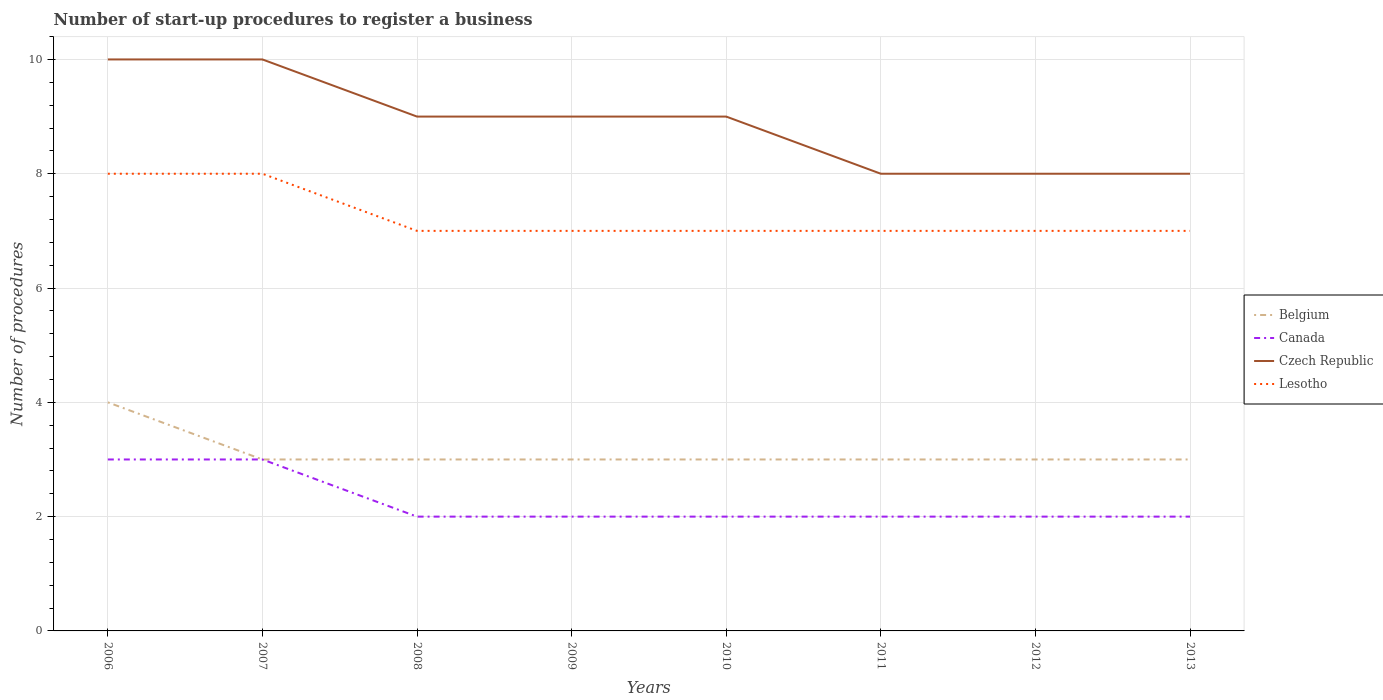How many different coloured lines are there?
Keep it short and to the point. 4. Does the line corresponding to Czech Republic intersect with the line corresponding to Canada?
Provide a succinct answer. No. Is the number of lines equal to the number of legend labels?
Provide a succinct answer. Yes. Across all years, what is the maximum number of procedures required to register a business in Lesotho?
Make the answer very short. 7. In which year was the number of procedures required to register a business in Belgium maximum?
Your answer should be compact. 2007. What is the difference between the highest and the second highest number of procedures required to register a business in Czech Republic?
Your answer should be compact. 2. What is the difference between the highest and the lowest number of procedures required to register a business in Canada?
Make the answer very short. 2. How many lines are there?
Offer a terse response. 4. How many years are there in the graph?
Keep it short and to the point. 8. What is the difference between two consecutive major ticks on the Y-axis?
Your answer should be very brief. 2. Does the graph contain any zero values?
Ensure brevity in your answer.  No. Where does the legend appear in the graph?
Offer a very short reply. Center right. How are the legend labels stacked?
Offer a very short reply. Vertical. What is the title of the graph?
Ensure brevity in your answer.  Number of start-up procedures to register a business. What is the label or title of the Y-axis?
Your answer should be very brief. Number of procedures. What is the Number of procedures in Belgium in 2007?
Your response must be concise. 3. What is the Number of procedures in Lesotho in 2007?
Provide a short and direct response. 8. What is the Number of procedures of Czech Republic in 2008?
Keep it short and to the point. 9. What is the Number of procedures of Lesotho in 2008?
Your answer should be compact. 7. What is the Number of procedures of Belgium in 2009?
Ensure brevity in your answer.  3. What is the Number of procedures in Canada in 2009?
Your response must be concise. 2. What is the Number of procedures in Lesotho in 2009?
Your answer should be very brief. 7. What is the Number of procedures in Belgium in 2010?
Give a very brief answer. 3. What is the Number of procedures in Canada in 2010?
Ensure brevity in your answer.  2. What is the Number of procedures in Czech Republic in 2010?
Your answer should be very brief. 9. What is the Number of procedures in Lesotho in 2010?
Give a very brief answer. 7. What is the Number of procedures in Canada in 2011?
Provide a short and direct response. 2. What is the Number of procedures in Czech Republic in 2011?
Provide a succinct answer. 8. What is the Number of procedures in Lesotho in 2011?
Provide a succinct answer. 7. What is the Number of procedures in Belgium in 2012?
Provide a short and direct response. 3. What is the Number of procedures of Lesotho in 2012?
Offer a very short reply. 7. What is the Number of procedures of Belgium in 2013?
Provide a short and direct response. 3. What is the Number of procedures in Lesotho in 2013?
Keep it short and to the point. 7. Across all years, what is the maximum Number of procedures in Belgium?
Provide a succinct answer. 4. Across all years, what is the minimum Number of procedures in Belgium?
Keep it short and to the point. 3. Across all years, what is the minimum Number of procedures of Canada?
Your answer should be compact. 2. Across all years, what is the minimum Number of procedures in Czech Republic?
Give a very brief answer. 8. Across all years, what is the minimum Number of procedures of Lesotho?
Give a very brief answer. 7. What is the total Number of procedures in Czech Republic in the graph?
Offer a very short reply. 71. What is the difference between the Number of procedures of Belgium in 2006 and that in 2007?
Offer a very short reply. 1. What is the difference between the Number of procedures in Canada in 2006 and that in 2007?
Provide a short and direct response. 0. What is the difference between the Number of procedures in Czech Republic in 2006 and that in 2007?
Offer a very short reply. 0. What is the difference between the Number of procedures in Lesotho in 2006 and that in 2007?
Ensure brevity in your answer.  0. What is the difference between the Number of procedures in Belgium in 2006 and that in 2008?
Make the answer very short. 1. What is the difference between the Number of procedures of Canada in 2006 and that in 2008?
Your answer should be compact. 1. What is the difference between the Number of procedures in Lesotho in 2006 and that in 2008?
Ensure brevity in your answer.  1. What is the difference between the Number of procedures in Belgium in 2006 and that in 2009?
Your answer should be compact. 1. What is the difference between the Number of procedures of Belgium in 2006 and that in 2010?
Give a very brief answer. 1. What is the difference between the Number of procedures in Canada in 2006 and that in 2010?
Keep it short and to the point. 1. What is the difference between the Number of procedures of Czech Republic in 2006 and that in 2010?
Make the answer very short. 1. What is the difference between the Number of procedures in Belgium in 2006 and that in 2011?
Your answer should be very brief. 1. What is the difference between the Number of procedures in Canada in 2006 and that in 2011?
Your response must be concise. 1. What is the difference between the Number of procedures in Czech Republic in 2006 and that in 2011?
Keep it short and to the point. 2. What is the difference between the Number of procedures of Belgium in 2006 and that in 2012?
Ensure brevity in your answer.  1. What is the difference between the Number of procedures in Lesotho in 2006 and that in 2012?
Give a very brief answer. 1. What is the difference between the Number of procedures in Belgium in 2006 and that in 2013?
Give a very brief answer. 1. What is the difference between the Number of procedures in Canada in 2006 and that in 2013?
Offer a terse response. 1. What is the difference between the Number of procedures of Lesotho in 2006 and that in 2013?
Keep it short and to the point. 1. What is the difference between the Number of procedures of Canada in 2007 and that in 2008?
Keep it short and to the point. 1. What is the difference between the Number of procedures in Belgium in 2007 and that in 2009?
Make the answer very short. 0. What is the difference between the Number of procedures of Czech Republic in 2007 and that in 2009?
Your response must be concise. 1. What is the difference between the Number of procedures of Belgium in 2007 and that in 2010?
Offer a very short reply. 0. What is the difference between the Number of procedures in Canada in 2007 and that in 2010?
Offer a very short reply. 1. What is the difference between the Number of procedures in Czech Republic in 2007 and that in 2011?
Make the answer very short. 2. What is the difference between the Number of procedures in Lesotho in 2007 and that in 2011?
Your response must be concise. 1. What is the difference between the Number of procedures of Belgium in 2007 and that in 2012?
Your answer should be compact. 0. What is the difference between the Number of procedures in Czech Republic in 2007 and that in 2012?
Offer a very short reply. 2. What is the difference between the Number of procedures of Lesotho in 2007 and that in 2012?
Offer a very short reply. 1. What is the difference between the Number of procedures in Belgium in 2007 and that in 2013?
Give a very brief answer. 0. What is the difference between the Number of procedures in Canada in 2007 and that in 2013?
Give a very brief answer. 1. What is the difference between the Number of procedures of Czech Republic in 2007 and that in 2013?
Keep it short and to the point. 2. What is the difference between the Number of procedures in Lesotho in 2007 and that in 2013?
Keep it short and to the point. 1. What is the difference between the Number of procedures of Belgium in 2008 and that in 2009?
Give a very brief answer. 0. What is the difference between the Number of procedures of Czech Republic in 2008 and that in 2009?
Keep it short and to the point. 0. What is the difference between the Number of procedures in Belgium in 2008 and that in 2010?
Keep it short and to the point. 0. What is the difference between the Number of procedures of Canada in 2008 and that in 2010?
Give a very brief answer. 0. What is the difference between the Number of procedures in Czech Republic in 2008 and that in 2010?
Offer a terse response. 0. What is the difference between the Number of procedures in Lesotho in 2008 and that in 2010?
Your answer should be very brief. 0. What is the difference between the Number of procedures in Canada in 2008 and that in 2011?
Offer a terse response. 0. What is the difference between the Number of procedures in Czech Republic in 2008 and that in 2011?
Your answer should be compact. 1. What is the difference between the Number of procedures in Canada in 2008 and that in 2012?
Your answer should be very brief. 0. What is the difference between the Number of procedures in Lesotho in 2008 and that in 2012?
Your answer should be very brief. 0. What is the difference between the Number of procedures of Czech Republic in 2008 and that in 2013?
Your answer should be very brief. 1. What is the difference between the Number of procedures of Canada in 2009 and that in 2010?
Your answer should be very brief. 0. What is the difference between the Number of procedures of Belgium in 2009 and that in 2011?
Your answer should be very brief. 0. What is the difference between the Number of procedures in Czech Republic in 2009 and that in 2011?
Provide a short and direct response. 1. What is the difference between the Number of procedures in Lesotho in 2009 and that in 2011?
Offer a very short reply. 0. What is the difference between the Number of procedures in Belgium in 2009 and that in 2012?
Give a very brief answer. 0. What is the difference between the Number of procedures in Canada in 2009 and that in 2012?
Offer a terse response. 0. What is the difference between the Number of procedures in Czech Republic in 2009 and that in 2012?
Offer a very short reply. 1. What is the difference between the Number of procedures in Canada in 2009 and that in 2013?
Provide a short and direct response. 0. What is the difference between the Number of procedures of Lesotho in 2009 and that in 2013?
Offer a terse response. 0. What is the difference between the Number of procedures of Canada in 2010 and that in 2011?
Keep it short and to the point. 0. What is the difference between the Number of procedures in Canada in 2010 and that in 2012?
Ensure brevity in your answer.  0. What is the difference between the Number of procedures of Czech Republic in 2010 and that in 2012?
Keep it short and to the point. 1. What is the difference between the Number of procedures in Lesotho in 2010 and that in 2012?
Offer a very short reply. 0. What is the difference between the Number of procedures of Belgium in 2011 and that in 2012?
Provide a short and direct response. 0. What is the difference between the Number of procedures in Canada in 2011 and that in 2012?
Offer a very short reply. 0. What is the difference between the Number of procedures of Czech Republic in 2011 and that in 2012?
Ensure brevity in your answer.  0. What is the difference between the Number of procedures of Lesotho in 2011 and that in 2012?
Ensure brevity in your answer.  0. What is the difference between the Number of procedures in Belgium in 2011 and that in 2013?
Your answer should be compact. 0. What is the difference between the Number of procedures in Czech Republic in 2011 and that in 2013?
Provide a short and direct response. 0. What is the difference between the Number of procedures in Canada in 2012 and that in 2013?
Provide a short and direct response. 0. What is the difference between the Number of procedures of Czech Republic in 2012 and that in 2013?
Your response must be concise. 0. What is the difference between the Number of procedures of Lesotho in 2012 and that in 2013?
Give a very brief answer. 0. What is the difference between the Number of procedures of Belgium in 2006 and the Number of procedures of Lesotho in 2007?
Provide a succinct answer. -4. What is the difference between the Number of procedures of Belgium in 2006 and the Number of procedures of Czech Republic in 2008?
Make the answer very short. -5. What is the difference between the Number of procedures in Belgium in 2006 and the Number of procedures in Lesotho in 2008?
Give a very brief answer. -3. What is the difference between the Number of procedures of Canada in 2006 and the Number of procedures of Czech Republic in 2008?
Your answer should be very brief. -6. What is the difference between the Number of procedures in Canada in 2006 and the Number of procedures in Lesotho in 2008?
Provide a short and direct response. -4. What is the difference between the Number of procedures of Czech Republic in 2006 and the Number of procedures of Lesotho in 2008?
Offer a terse response. 3. What is the difference between the Number of procedures in Belgium in 2006 and the Number of procedures in Czech Republic in 2009?
Your answer should be compact. -5. What is the difference between the Number of procedures of Belgium in 2006 and the Number of procedures of Lesotho in 2009?
Provide a succinct answer. -3. What is the difference between the Number of procedures in Canada in 2006 and the Number of procedures in Czech Republic in 2009?
Offer a terse response. -6. What is the difference between the Number of procedures in Belgium in 2006 and the Number of procedures in Canada in 2010?
Give a very brief answer. 2. What is the difference between the Number of procedures of Belgium in 2006 and the Number of procedures of Lesotho in 2010?
Provide a succinct answer. -3. What is the difference between the Number of procedures of Belgium in 2006 and the Number of procedures of Canada in 2011?
Your response must be concise. 2. What is the difference between the Number of procedures of Belgium in 2006 and the Number of procedures of Czech Republic in 2011?
Your response must be concise. -4. What is the difference between the Number of procedures of Canada in 2006 and the Number of procedures of Czech Republic in 2011?
Your answer should be compact. -5. What is the difference between the Number of procedures in Czech Republic in 2006 and the Number of procedures in Lesotho in 2011?
Your response must be concise. 3. What is the difference between the Number of procedures in Belgium in 2006 and the Number of procedures in Canada in 2012?
Provide a short and direct response. 2. What is the difference between the Number of procedures of Canada in 2006 and the Number of procedures of Czech Republic in 2012?
Give a very brief answer. -5. What is the difference between the Number of procedures in Canada in 2006 and the Number of procedures in Lesotho in 2012?
Make the answer very short. -4. What is the difference between the Number of procedures in Czech Republic in 2006 and the Number of procedures in Lesotho in 2012?
Offer a terse response. 3. What is the difference between the Number of procedures of Belgium in 2006 and the Number of procedures of Czech Republic in 2013?
Your answer should be very brief. -4. What is the difference between the Number of procedures of Belgium in 2007 and the Number of procedures of Canada in 2008?
Ensure brevity in your answer.  1. What is the difference between the Number of procedures of Belgium in 2007 and the Number of procedures of Lesotho in 2008?
Keep it short and to the point. -4. What is the difference between the Number of procedures of Canada in 2007 and the Number of procedures of Lesotho in 2008?
Offer a terse response. -4. What is the difference between the Number of procedures in Belgium in 2007 and the Number of procedures in Canada in 2009?
Your answer should be compact. 1. What is the difference between the Number of procedures of Belgium in 2007 and the Number of procedures of Lesotho in 2009?
Make the answer very short. -4. What is the difference between the Number of procedures of Canada in 2007 and the Number of procedures of Czech Republic in 2009?
Ensure brevity in your answer.  -6. What is the difference between the Number of procedures of Belgium in 2007 and the Number of procedures of Canada in 2010?
Keep it short and to the point. 1. What is the difference between the Number of procedures in Belgium in 2007 and the Number of procedures in Czech Republic in 2010?
Your response must be concise. -6. What is the difference between the Number of procedures of Canada in 2007 and the Number of procedures of Czech Republic in 2010?
Offer a terse response. -6. What is the difference between the Number of procedures of Czech Republic in 2007 and the Number of procedures of Lesotho in 2010?
Give a very brief answer. 3. What is the difference between the Number of procedures of Belgium in 2007 and the Number of procedures of Canada in 2011?
Your answer should be compact. 1. What is the difference between the Number of procedures of Belgium in 2007 and the Number of procedures of Lesotho in 2011?
Offer a very short reply. -4. What is the difference between the Number of procedures in Canada in 2007 and the Number of procedures in Czech Republic in 2011?
Give a very brief answer. -5. What is the difference between the Number of procedures in Canada in 2007 and the Number of procedures in Lesotho in 2011?
Provide a succinct answer. -4. What is the difference between the Number of procedures of Belgium in 2007 and the Number of procedures of Canada in 2012?
Your answer should be very brief. 1. What is the difference between the Number of procedures of Canada in 2007 and the Number of procedures of Czech Republic in 2012?
Your answer should be very brief. -5. What is the difference between the Number of procedures of Canada in 2007 and the Number of procedures of Lesotho in 2012?
Your answer should be very brief. -4. What is the difference between the Number of procedures in Czech Republic in 2007 and the Number of procedures in Lesotho in 2012?
Make the answer very short. 3. What is the difference between the Number of procedures in Belgium in 2007 and the Number of procedures in Canada in 2013?
Your answer should be very brief. 1. What is the difference between the Number of procedures of Belgium in 2007 and the Number of procedures of Czech Republic in 2013?
Your answer should be compact. -5. What is the difference between the Number of procedures in Canada in 2007 and the Number of procedures in Czech Republic in 2013?
Offer a terse response. -5. What is the difference between the Number of procedures of Czech Republic in 2007 and the Number of procedures of Lesotho in 2013?
Your response must be concise. 3. What is the difference between the Number of procedures of Canada in 2008 and the Number of procedures of Czech Republic in 2009?
Your answer should be compact. -7. What is the difference between the Number of procedures in Belgium in 2008 and the Number of procedures in Canada in 2010?
Provide a succinct answer. 1. What is the difference between the Number of procedures in Belgium in 2008 and the Number of procedures in Czech Republic in 2010?
Offer a very short reply. -6. What is the difference between the Number of procedures in Czech Republic in 2008 and the Number of procedures in Lesotho in 2010?
Make the answer very short. 2. What is the difference between the Number of procedures in Belgium in 2008 and the Number of procedures in Canada in 2011?
Your answer should be very brief. 1. What is the difference between the Number of procedures in Belgium in 2008 and the Number of procedures in Czech Republic in 2011?
Your response must be concise. -5. What is the difference between the Number of procedures of Belgium in 2008 and the Number of procedures of Lesotho in 2011?
Provide a succinct answer. -4. What is the difference between the Number of procedures of Canada in 2008 and the Number of procedures of Lesotho in 2011?
Ensure brevity in your answer.  -5. What is the difference between the Number of procedures of Belgium in 2008 and the Number of procedures of Czech Republic in 2012?
Your answer should be very brief. -5. What is the difference between the Number of procedures in Canada in 2008 and the Number of procedures in Czech Republic in 2012?
Provide a short and direct response. -6. What is the difference between the Number of procedures of Canada in 2008 and the Number of procedures of Lesotho in 2012?
Your answer should be compact. -5. What is the difference between the Number of procedures in Czech Republic in 2008 and the Number of procedures in Lesotho in 2012?
Provide a short and direct response. 2. What is the difference between the Number of procedures of Belgium in 2008 and the Number of procedures of Canada in 2013?
Your answer should be compact. 1. What is the difference between the Number of procedures in Belgium in 2008 and the Number of procedures in Lesotho in 2013?
Your answer should be compact. -4. What is the difference between the Number of procedures in Canada in 2008 and the Number of procedures in Czech Republic in 2013?
Your response must be concise. -6. What is the difference between the Number of procedures in Canada in 2008 and the Number of procedures in Lesotho in 2013?
Offer a very short reply. -5. What is the difference between the Number of procedures in Czech Republic in 2008 and the Number of procedures in Lesotho in 2013?
Your answer should be compact. 2. What is the difference between the Number of procedures in Belgium in 2009 and the Number of procedures in Canada in 2010?
Offer a terse response. 1. What is the difference between the Number of procedures of Belgium in 2009 and the Number of procedures of Lesotho in 2010?
Ensure brevity in your answer.  -4. What is the difference between the Number of procedures of Canada in 2009 and the Number of procedures of Lesotho in 2010?
Give a very brief answer. -5. What is the difference between the Number of procedures in Czech Republic in 2009 and the Number of procedures in Lesotho in 2010?
Your answer should be compact. 2. What is the difference between the Number of procedures of Belgium in 2009 and the Number of procedures of Lesotho in 2011?
Keep it short and to the point. -4. What is the difference between the Number of procedures of Canada in 2009 and the Number of procedures of Czech Republic in 2011?
Give a very brief answer. -6. What is the difference between the Number of procedures in Canada in 2009 and the Number of procedures in Lesotho in 2011?
Your answer should be compact. -5. What is the difference between the Number of procedures in Belgium in 2009 and the Number of procedures in Czech Republic in 2012?
Make the answer very short. -5. What is the difference between the Number of procedures in Belgium in 2009 and the Number of procedures in Lesotho in 2012?
Offer a very short reply. -4. What is the difference between the Number of procedures of Canada in 2009 and the Number of procedures of Lesotho in 2012?
Your response must be concise. -5. What is the difference between the Number of procedures in Czech Republic in 2009 and the Number of procedures in Lesotho in 2012?
Your response must be concise. 2. What is the difference between the Number of procedures of Belgium in 2009 and the Number of procedures of Czech Republic in 2013?
Offer a very short reply. -5. What is the difference between the Number of procedures of Belgium in 2009 and the Number of procedures of Lesotho in 2013?
Offer a terse response. -4. What is the difference between the Number of procedures in Canada in 2009 and the Number of procedures in Czech Republic in 2013?
Provide a succinct answer. -6. What is the difference between the Number of procedures of Canada in 2009 and the Number of procedures of Lesotho in 2013?
Offer a terse response. -5. What is the difference between the Number of procedures of Czech Republic in 2009 and the Number of procedures of Lesotho in 2013?
Your answer should be compact. 2. What is the difference between the Number of procedures in Belgium in 2010 and the Number of procedures in Czech Republic in 2011?
Give a very brief answer. -5. What is the difference between the Number of procedures in Canada in 2010 and the Number of procedures in Czech Republic in 2011?
Provide a short and direct response. -6. What is the difference between the Number of procedures of Czech Republic in 2010 and the Number of procedures of Lesotho in 2011?
Offer a terse response. 2. What is the difference between the Number of procedures in Belgium in 2010 and the Number of procedures in Lesotho in 2012?
Offer a terse response. -4. What is the difference between the Number of procedures in Canada in 2010 and the Number of procedures in Czech Republic in 2012?
Provide a succinct answer. -6. What is the difference between the Number of procedures of Czech Republic in 2010 and the Number of procedures of Lesotho in 2012?
Your response must be concise. 2. What is the difference between the Number of procedures of Czech Republic in 2010 and the Number of procedures of Lesotho in 2013?
Provide a short and direct response. 2. What is the difference between the Number of procedures in Belgium in 2011 and the Number of procedures in Czech Republic in 2012?
Provide a succinct answer. -5. What is the difference between the Number of procedures in Canada in 2011 and the Number of procedures in Czech Republic in 2012?
Offer a terse response. -6. What is the difference between the Number of procedures in Canada in 2011 and the Number of procedures in Lesotho in 2012?
Your answer should be compact. -5. What is the difference between the Number of procedures of Czech Republic in 2011 and the Number of procedures of Lesotho in 2012?
Your response must be concise. 1. What is the difference between the Number of procedures in Belgium in 2011 and the Number of procedures in Canada in 2013?
Ensure brevity in your answer.  1. What is the difference between the Number of procedures in Belgium in 2011 and the Number of procedures in Lesotho in 2013?
Offer a terse response. -4. What is the difference between the Number of procedures of Canada in 2011 and the Number of procedures of Lesotho in 2013?
Your answer should be compact. -5. What is the difference between the Number of procedures in Czech Republic in 2011 and the Number of procedures in Lesotho in 2013?
Give a very brief answer. 1. What is the difference between the Number of procedures in Belgium in 2012 and the Number of procedures in Canada in 2013?
Offer a very short reply. 1. What is the difference between the Number of procedures of Belgium in 2012 and the Number of procedures of Czech Republic in 2013?
Offer a terse response. -5. What is the difference between the Number of procedures of Canada in 2012 and the Number of procedures of Lesotho in 2013?
Provide a short and direct response. -5. What is the average Number of procedures of Belgium per year?
Offer a terse response. 3.12. What is the average Number of procedures in Canada per year?
Give a very brief answer. 2.25. What is the average Number of procedures in Czech Republic per year?
Provide a short and direct response. 8.88. What is the average Number of procedures in Lesotho per year?
Keep it short and to the point. 7.25. In the year 2006, what is the difference between the Number of procedures of Belgium and Number of procedures of Canada?
Your response must be concise. 1. In the year 2006, what is the difference between the Number of procedures of Belgium and Number of procedures of Czech Republic?
Your response must be concise. -6. In the year 2007, what is the difference between the Number of procedures of Belgium and Number of procedures of Canada?
Provide a short and direct response. 0. In the year 2007, what is the difference between the Number of procedures of Belgium and Number of procedures of Lesotho?
Provide a succinct answer. -5. In the year 2007, what is the difference between the Number of procedures in Canada and Number of procedures in Czech Republic?
Provide a short and direct response. -7. In the year 2007, what is the difference between the Number of procedures of Canada and Number of procedures of Lesotho?
Give a very brief answer. -5. In the year 2008, what is the difference between the Number of procedures in Belgium and Number of procedures in Canada?
Your answer should be compact. 1. In the year 2009, what is the difference between the Number of procedures in Belgium and Number of procedures in Canada?
Give a very brief answer. 1. In the year 2009, what is the difference between the Number of procedures of Canada and Number of procedures of Czech Republic?
Ensure brevity in your answer.  -7. In the year 2009, what is the difference between the Number of procedures of Czech Republic and Number of procedures of Lesotho?
Your response must be concise. 2. In the year 2010, what is the difference between the Number of procedures in Belgium and Number of procedures in Canada?
Offer a very short reply. 1. In the year 2010, what is the difference between the Number of procedures of Canada and Number of procedures of Lesotho?
Provide a succinct answer. -5. In the year 2010, what is the difference between the Number of procedures of Czech Republic and Number of procedures of Lesotho?
Offer a very short reply. 2. In the year 2011, what is the difference between the Number of procedures in Belgium and Number of procedures in Lesotho?
Offer a very short reply. -4. In the year 2011, what is the difference between the Number of procedures in Canada and Number of procedures in Czech Republic?
Give a very brief answer. -6. In the year 2011, what is the difference between the Number of procedures of Czech Republic and Number of procedures of Lesotho?
Give a very brief answer. 1. In the year 2012, what is the difference between the Number of procedures in Belgium and Number of procedures in Czech Republic?
Ensure brevity in your answer.  -5. In the year 2012, what is the difference between the Number of procedures in Canada and Number of procedures in Czech Republic?
Keep it short and to the point. -6. In the year 2012, what is the difference between the Number of procedures in Canada and Number of procedures in Lesotho?
Make the answer very short. -5. In the year 2012, what is the difference between the Number of procedures in Czech Republic and Number of procedures in Lesotho?
Keep it short and to the point. 1. In the year 2013, what is the difference between the Number of procedures of Belgium and Number of procedures of Czech Republic?
Make the answer very short. -5. In the year 2013, what is the difference between the Number of procedures in Belgium and Number of procedures in Lesotho?
Your answer should be very brief. -4. In the year 2013, what is the difference between the Number of procedures of Canada and Number of procedures of Czech Republic?
Offer a very short reply. -6. In the year 2013, what is the difference between the Number of procedures in Czech Republic and Number of procedures in Lesotho?
Your answer should be compact. 1. What is the ratio of the Number of procedures in Czech Republic in 2006 to that in 2007?
Provide a succinct answer. 1. What is the ratio of the Number of procedures of Belgium in 2006 to that in 2008?
Your answer should be compact. 1.33. What is the ratio of the Number of procedures in Canada in 2006 to that in 2008?
Make the answer very short. 1.5. What is the ratio of the Number of procedures in Belgium in 2006 to that in 2009?
Keep it short and to the point. 1.33. What is the ratio of the Number of procedures of Lesotho in 2006 to that in 2009?
Provide a short and direct response. 1.14. What is the ratio of the Number of procedures of Belgium in 2006 to that in 2010?
Offer a very short reply. 1.33. What is the ratio of the Number of procedures in Canada in 2006 to that in 2010?
Your response must be concise. 1.5. What is the ratio of the Number of procedures of Canada in 2006 to that in 2011?
Your response must be concise. 1.5. What is the ratio of the Number of procedures in Belgium in 2006 to that in 2012?
Keep it short and to the point. 1.33. What is the ratio of the Number of procedures in Canada in 2006 to that in 2012?
Your answer should be compact. 1.5. What is the ratio of the Number of procedures of Czech Republic in 2006 to that in 2012?
Keep it short and to the point. 1.25. What is the ratio of the Number of procedures in Lesotho in 2006 to that in 2013?
Keep it short and to the point. 1.14. What is the ratio of the Number of procedures in Canada in 2007 to that in 2009?
Provide a short and direct response. 1.5. What is the ratio of the Number of procedures in Czech Republic in 2007 to that in 2009?
Offer a very short reply. 1.11. What is the ratio of the Number of procedures of Lesotho in 2007 to that in 2009?
Provide a succinct answer. 1.14. What is the ratio of the Number of procedures of Canada in 2007 to that in 2010?
Give a very brief answer. 1.5. What is the ratio of the Number of procedures in Czech Republic in 2007 to that in 2010?
Your answer should be very brief. 1.11. What is the ratio of the Number of procedures of Canada in 2007 to that in 2011?
Your answer should be very brief. 1.5. What is the ratio of the Number of procedures in Canada in 2007 to that in 2012?
Your response must be concise. 1.5. What is the ratio of the Number of procedures of Czech Republic in 2007 to that in 2012?
Offer a very short reply. 1.25. What is the ratio of the Number of procedures of Lesotho in 2007 to that in 2012?
Provide a short and direct response. 1.14. What is the ratio of the Number of procedures of Canada in 2007 to that in 2013?
Ensure brevity in your answer.  1.5. What is the ratio of the Number of procedures in Canada in 2008 to that in 2009?
Your response must be concise. 1. What is the ratio of the Number of procedures of Belgium in 2008 to that in 2010?
Offer a terse response. 1. What is the ratio of the Number of procedures of Czech Republic in 2008 to that in 2010?
Keep it short and to the point. 1. What is the ratio of the Number of procedures of Lesotho in 2008 to that in 2010?
Offer a very short reply. 1. What is the ratio of the Number of procedures in Canada in 2008 to that in 2011?
Keep it short and to the point. 1. What is the ratio of the Number of procedures of Lesotho in 2008 to that in 2011?
Offer a terse response. 1. What is the ratio of the Number of procedures in Lesotho in 2008 to that in 2012?
Offer a terse response. 1. What is the ratio of the Number of procedures of Belgium in 2008 to that in 2013?
Ensure brevity in your answer.  1. What is the ratio of the Number of procedures of Canada in 2008 to that in 2013?
Make the answer very short. 1. What is the ratio of the Number of procedures in Czech Republic in 2008 to that in 2013?
Provide a short and direct response. 1.12. What is the ratio of the Number of procedures in Czech Republic in 2009 to that in 2010?
Make the answer very short. 1. What is the ratio of the Number of procedures of Lesotho in 2009 to that in 2010?
Your answer should be compact. 1. What is the ratio of the Number of procedures in Canada in 2009 to that in 2011?
Your answer should be very brief. 1. What is the ratio of the Number of procedures in Lesotho in 2009 to that in 2011?
Offer a terse response. 1. What is the ratio of the Number of procedures in Czech Republic in 2009 to that in 2012?
Offer a terse response. 1.12. What is the ratio of the Number of procedures in Belgium in 2009 to that in 2013?
Make the answer very short. 1. What is the ratio of the Number of procedures of Canada in 2009 to that in 2013?
Offer a very short reply. 1. What is the ratio of the Number of procedures in Czech Republic in 2009 to that in 2013?
Offer a terse response. 1.12. What is the ratio of the Number of procedures in Lesotho in 2009 to that in 2013?
Provide a short and direct response. 1. What is the ratio of the Number of procedures in Czech Republic in 2010 to that in 2011?
Offer a very short reply. 1.12. What is the ratio of the Number of procedures of Lesotho in 2010 to that in 2011?
Provide a succinct answer. 1. What is the ratio of the Number of procedures of Canada in 2010 to that in 2012?
Your answer should be compact. 1. What is the ratio of the Number of procedures of Belgium in 2010 to that in 2013?
Your answer should be compact. 1. What is the ratio of the Number of procedures of Canada in 2010 to that in 2013?
Provide a short and direct response. 1. What is the ratio of the Number of procedures in Czech Republic in 2010 to that in 2013?
Keep it short and to the point. 1.12. What is the ratio of the Number of procedures in Lesotho in 2010 to that in 2013?
Your answer should be very brief. 1. What is the ratio of the Number of procedures in Belgium in 2011 to that in 2012?
Your answer should be compact. 1. What is the ratio of the Number of procedures of Czech Republic in 2011 to that in 2012?
Your answer should be compact. 1. What is the ratio of the Number of procedures of Lesotho in 2011 to that in 2012?
Provide a succinct answer. 1. What is the ratio of the Number of procedures of Czech Republic in 2011 to that in 2013?
Ensure brevity in your answer.  1. What is the ratio of the Number of procedures of Lesotho in 2011 to that in 2013?
Your answer should be very brief. 1. What is the ratio of the Number of procedures in Canada in 2012 to that in 2013?
Your response must be concise. 1. What is the ratio of the Number of procedures of Lesotho in 2012 to that in 2013?
Your answer should be compact. 1. What is the difference between the highest and the second highest Number of procedures of Canada?
Offer a very short reply. 0. What is the difference between the highest and the second highest Number of procedures of Lesotho?
Ensure brevity in your answer.  0. What is the difference between the highest and the lowest Number of procedures in Canada?
Offer a terse response. 1. 